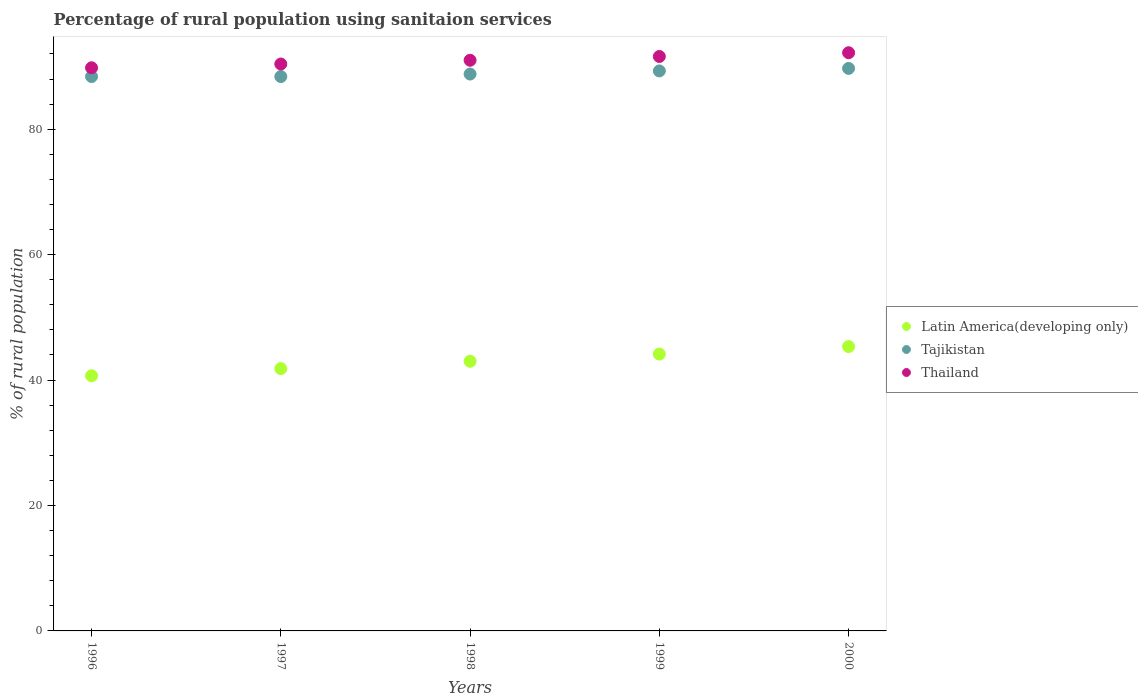Is the number of dotlines equal to the number of legend labels?
Your answer should be very brief. Yes. What is the percentage of rural population using sanitaion services in Tajikistan in 1997?
Provide a short and direct response. 88.4. Across all years, what is the maximum percentage of rural population using sanitaion services in Thailand?
Offer a terse response. 92.2. Across all years, what is the minimum percentage of rural population using sanitaion services in Thailand?
Offer a terse response. 89.8. What is the total percentage of rural population using sanitaion services in Latin America(developing only) in the graph?
Your answer should be very brief. 215.01. What is the difference between the percentage of rural population using sanitaion services in Thailand in 1997 and that in 1999?
Your response must be concise. -1.2. What is the difference between the percentage of rural population using sanitaion services in Latin America(developing only) in 1998 and the percentage of rural population using sanitaion services in Tajikistan in 2000?
Your answer should be very brief. -46.7. What is the average percentage of rural population using sanitaion services in Thailand per year?
Provide a short and direct response. 91. In the year 1996, what is the difference between the percentage of rural population using sanitaion services in Tajikistan and percentage of rural population using sanitaion services in Latin America(developing only)?
Your response must be concise. 47.71. What is the ratio of the percentage of rural population using sanitaion services in Latin America(developing only) in 1996 to that in 2000?
Ensure brevity in your answer.  0.9. Is the percentage of rural population using sanitaion services in Tajikistan in 1997 less than that in 2000?
Ensure brevity in your answer.  Yes. Is the difference between the percentage of rural population using sanitaion services in Tajikistan in 1996 and 1999 greater than the difference between the percentage of rural population using sanitaion services in Latin America(developing only) in 1996 and 1999?
Offer a terse response. Yes. What is the difference between the highest and the second highest percentage of rural population using sanitaion services in Tajikistan?
Your answer should be compact. 0.4. What is the difference between the highest and the lowest percentage of rural population using sanitaion services in Latin America(developing only)?
Your response must be concise. 4.65. In how many years, is the percentage of rural population using sanitaion services in Tajikistan greater than the average percentage of rural population using sanitaion services in Tajikistan taken over all years?
Your answer should be compact. 2. Is it the case that in every year, the sum of the percentage of rural population using sanitaion services in Latin America(developing only) and percentage of rural population using sanitaion services in Thailand  is greater than the percentage of rural population using sanitaion services in Tajikistan?
Your answer should be compact. Yes. Does the percentage of rural population using sanitaion services in Tajikistan monotonically increase over the years?
Ensure brevity in your answer.  No. Is the percentage of rural population using sanitaion services in Latin America(developing only) strictly greater than the percentage of rural population using sanitaion services in Thailand over the years?
Give a very brief answer. No. What is the difference between two consecutive major ticks on the Y-axis?
Your answer should be very brief. 20. Does the graph contain any zero values?
Provide a short and direct response. No. Does the graph contain grids?
Make the answer very short. No. What is the title of the graph?
Offer a very short reply. Percentage of rural population using sanitaion services. What is the label or title of the Y-axis?
Offer a very short reply. % of rural population. What is the % of rural population of Latin America(developing only) in 1996?
Your answer should be very brief. 40.69. What is the % of rural population of Tajikistan in 1996?
Offer a terse response. 88.4. What is the % of rural population in Thailand in 1996?
Offer a terse response. 89.8. What is the % of rural population of Latin America(developing only) in 1997?
Your response must be concise. 41.83. What is the % of rural population of Tajikistan in 1997?
Keep it short and to the point. 88.4. What is the % of rural population in Thailand in 1997?
Offer a very short reply. 90.4. What is the % of rural population of Latin America(developing only) in 1998?
Make the answer very short. 43. What is the % of rural population of Tajikistan in 1998?
Offer a terse response. 88.8. What is the % of rural population of Thailand in 1998?
Make the answer very short. 91. What is the % of rural population of Latin America(developing only) in 1999?
Offer a terse response. 44.15. What is the % of rural population of Tajikistan in 1999?
Your response must be concise. 89.3. What is the % of rural population of Thailand in 1999?
Offer a very short reply. 91.6. What is the % of rural population of Latin America(developing only) in 2000?
Give a very brief answer. 45.34. What is the % of rural population in Tajikistan in 2000?
Offer a terse response. 89.7. What is the % of rural population of Thailand in 2000?
Provide a succinct answer. 92.2. Across all years, what is the maximum % of rural population in Latin America(developing only)?
Offer a terse response. 45.34. Across all years, what is the maximum % of rural population of Tajikistan?
Your response must be concise. 89.7. Across all years, what is the maximum % of rural population of Thailand?
Your answer should be compact. 92.2. Across all years, what is the minimum % of rural population of Latin America(developing only)?
Give a very brief answer. 40.69. Across all years, what is the minimum % of rural population of Tajikistan?
Give a very brief answer. 88.4. Across all years, what is the minimum % of rural population of Thailand?
Your answer should be compact. 89.8. What is the total % of rural population in Latin America(developing only) in the graph?
Give a very brief answer. 215.01. What is the total % of rural population of Tajikistan in the graph?
Make the answer very short. 444.6. What is the total % of rural population of Thailand in the graph?
Offer a terse response. 455. What is the difference between the % of rural population of Latin America(developing only) in 1996 and that in 1997?
Provide a short and direct response. -1.14. What is the difference between the % of rural population in Tajikistan in 1996 and that in 1997?
Your response must be concise. 0. What is the difference between the % of rural population of Latin America(developing only) in 1996 and that in 1998?
Ensure brevity in your answer.  -2.31. What is the difference between the % of rural population in Latin America(developing only) in 1996 and that in 1999?
Offer a very short reply. -3.46. What is the difference between the % of rural population of Thailand in 1996 and that in 1999?
Make the answer very short. -1.8. What is the difference between the % of rural population of Latin America(developing only) in 1996 and that in 2000?
Your response must be concise. -4.65. What is the difference between the % of rural population in Tajikistan in 1996 and that in 2000?
Ensure brevity in your answer.  -1.3. What is the difference between the % of rural population in Thailand in 1996 and that in 2000?
Provide a succinct answer. -2.4. What is the difference between the % of rural population of Latin America(developing only) in 1997 and that in 1998?
Provide a short and direct response. -1.17. What is the difference between the % of rural population of Thailand in 1997 and that in 1998?
Provide a succinct answer. -0.6. What is the difference between the % of rural population of Latin America(developing only) in 1997 and that in 1999?
Offer a very short reply. -2.32. What is the difference between the % of rural population of Latin America(developing only) in 1997 and that in 2000?
Ensure brevity in your answer.  -3.51. What is the difference between the % of rural population of Tajikistan in 1997 and that in 2000?
Ensure brevity in your answer.  -1.3. What is the difference between the % of rural population in Thailand in 1997 and that in 2000?
Give a very brief answer. -1.8. What is the difference between the % of rural population of Latin America(developing only) in 1998 and that in 1999?
Offer a terse response. -1.15. What is the difference between the % of rural population of Tajikistan in 1998 and that in 1999?
Your response must be concise. -0.5. What is the difference between the % of rural population in Thailand in 1998 and that in 1999?
Provide a succinct answer. -0.6. What is the difference between the % of rural population of Latin America(developing only) in 1998 and that in 2000?
Offer a terse response. -2.34. What is the difference between the % of rural population in Latin America(developing only) in 1999 and that in 2000?
Offer a very short reply. -1.19. What is the difference between the % of rural population in Thailand in 1999 and that in 2000?
Offer a very short reply. -0.6. What is the difference between the % of rural population of Latin America(developing only) in 1996 and the % of rural population of Tajikistan in 1997?
Offer a terse response. -47.71. What is the difference between the % of rural population of Latin America(developing only) in 1996 and the % of rural population of Thailand in 1997?
Provide a succinct answer. -49.71. What is the difference between the % of rural population in Tajikistan in 1996 and the % of rural population in Thailand in 1997?
Give a very brief answer. -2. What is the difference between the % of rural population of Latin America(developing only) in 1996 and the % of rural population of Tajikistan in 1998?
Keep it short and to the point. -48.11. What is the difference between the % of rural population of Latin America(developing only) in 1996 and the % of rural population of Thailand in 1998?
Your response must be concise. -50.31. What is the difference between the % of rural population in Latin America(developing only) in 1996 and the % of rural population in Tajikistan in 1999?
Your answer should be very brief. -48.61. What is the difference between the % of rural population in Latin America(developing only) in 1996 and the % of rural population in Thailand in 1999?
Your answer should be compact. -50.91. What is the difference between the % of rural population of Tajikistan in 1996 and the % of rural population of Thailand in 1999?
Give a very brief answer. -3.2. What is the difference between the % of rural population in Latin America(developing only) in 1996 and the % of rural population in Tajikistan in 2000?
Offer a very short reply. -49.01. What is the difference between the % of rural population in Latin America(developing only) in 1996 and the % of rural population in Thailand in 2000?
Make the answer very short. -51.51. What is the difference between the % of rural population of Tajikistan in 1996 and the % of rural population of Thailand in 2000?
Give a very brief answer. -3.8. What is the difference between the % of rural population in Latin America(developing only) in 1997 and the % of rural population in Tajikistan in 1998?
Offer a very short reply. -46.97. What is the difference between the % of rural population in Latin America(developing only) in 1997 and the % of rural population in Thailand in 1998?
Give a very brief answer. -49.17. What is the difference between the % of rural population in Tajikistan in 1997 and the % of rural population in Thailand in 1998?
Provide a short and direct response. -2.6. What is the difference between the % of rural population in Latin America(developing only) in 1997 and the % of rural population in Tajikistan in 1999?
Provide a succinct answer. -47.47. What is the difference between the % of rural population of Latin America(developing only) in 1997 and the % of rural population of Thailand in 1999?
Keep it short and to the point. -49.77. What is the difference between the % of rural population of Latin America(developing only) in 1997 and the % of rural population of Tajikistan in 2000?
Ensure brevity in your answer.  -47.87. What is the difference between the % of rural population in Latin America(developing only) in 1997 and the % of rural population in Thailand in 2000?
Your answer should be very brief. -50.37. What is the difference between the % of rural population of Latin America(developing only) in 1998 and the % of rural population of Tajikistan in 1999?
Make the answer very short. -46.3. What is the difference between the % of rural population of Latin America(developing only) in 1998 and the % of rural population of Thailand in 1999?
Your answer should be very brief. -48.6. What is the difference between the % of rural population of Tajikistan in 1998 and the % of rural population of Thailand in 1999?
Offer a terse response. -2.8. What is the difference between the % of rural population of Latin America(developing only) in 1998 and the % of rural population of Tajikistan in 2000?
Your answer should be very brief. -46.7. What is the difference between the % of rural population in Latin America(developing only) in 1998 and the % of rural population in Thailand in 2000?
Keep it short and to the point. -49.2. What is the difference between the % of rural population of Tajikistan in 1998 and the % of rural population of Thailand in 2000?
Make the answer very short. -3.4. What is the difference between the % of rural population of Latin America(developing only) in 1999 and the % of rural population of Tajikistan in 2000?
Provide a short and direct response. -45.55. What is the difference between the % of rural population in Latin America(developing only) in 1999 and the % of rural population in Thailand in 2000?
Your response must be concise. -48.05. What is the difference between the % of rural population of Tajikistan in 1999 and the % of rural population of Thailand in 2000?
Offer a terse response. -2.9. What is the average % of rural population of Latin America(developing only) per year?
Give a very brief answer. 43. What is the average % of rural population in Tajikistan per year?
Provide a succinct answer. 88.92. What is the average % of rural population in Thailand per year?
Make the answer very short. 91. In the year 1996, what is the difference between the % of rural population of Latin America(developing only) and % of rural population of Tajikistan?
Your response must be concise. -47.71. In the year 1996, what is the difference between the % of rural population of Latin America(developing only) and % of rural population of Thailand?
Provide a short and direct response. -49.11. In the year 1996, what is the difference between the % of rural population in Tajikistan and % of rural population in Thailand?
Give a very brief answer. -1.4. In the year 1997, what is the difference between the % of rural population of Latin America(developing only) and % of rural population of Tajikistan?
Ensure brevity in your answer.  -46.57. In the year 1997, what is the difference between the % of rural population in Latin America(developing only) and % of rural population in Thailand?
Make the answer very short. -48.57. In the year 1997, what is the difference between the % of rural population of Tajikistan and % of rural population of Thailand?
Your answer should be very brief. -2. In the year 1998, what is the difference between the % of rural population in Latin America(developing only) and % of rural population in Tajikistan?
Your answer should be compact. -45.8. In the year 1998, what is the difference between the % of rural population of Latin America(developing only) and % of rural population of Thailand?
Provide a short and direct response. -48. In the year 1998, what is the difference between the % of rural population of Tajikistan and % of rural population of Thailand?
Your response must be concise. -2.2. In the year 1999, what is the difference between the % of rural population in Latin America(developing only) and % of rural population in Tajikistan?
Give a very brief answer. -45.15. In the year 1999, what is the difference between the % of rural population of Latin America(developing only) and % of rural population of Thailand?
Give a very brief answer. -47.45. In the year 1999, what is the difference between the % of rural population in Tajikistan and % of rural population in Thailand?
Provide a succinct answer. -2.3. In the year 2000, what is the difference between the % of rural population in Latin America(developing only) and % of rural population in Tajikistan?
Offer a very short reply. -44.36. In the year 2000, what is the difference between the % of rural population in Latin America(developing only) and % of rural population in Thailand?
Provide a succinct answer. -46.86. In the year 2000, what is the difference between the % of rural population in Tajikistan and % of rural population in Thailand?
Keep it short and to the point. -2.5. What is the ratio of the % of rural population in Latin America(developing only) in 1996 to that in 1997?
Make the answer very short. 0.97. What is the ratio of the % of rural population of Latin America(developing only) in 1996 to that in 1998?
Ensure brevity in your answer.  0.95. What is the ratio of the % of rural population of Tajikistan in 1996 to that in 1998?
Offer a very short reply. 1. What is the ratio of the % of rural population in Thailand in 1996 to that in 1998?
Offer a terse response. 0.99. What is the ratio of the % of rural population in Latin America(developing only) in 1996 to that in 1999?
Your answer should be compact. 0.92. What is the ratio of the % of rural population in Thailand in 1996 to that in 1999?
Provide a short and direct response. 0.98. What is the ratio of the % of rural population in Latin America(developing only) in 1996 to that in 2000?
Offer a very short reply. 0.9. What is the ratio of the % of rural population in Tajikistan in 1996 to that in 2000?
Your answer should be very brief. 0.99. What is the ratio of the % of rural population of Thailand in 1996 to that in 2000?
Offer a very short reply. 0.97. What is the ratio of the % of rural population in Latin America(developing only) in 1997 to that in 1998?
Offer a terse response. 0.97. What is the ratio of the % of rural population in Latin America(developing only) in 1997 to that in 1999?
Offer a terse response. 0.95. What is the ratio of the % of rural population in Thailand in 1997 to that in 1999?
Give a very brief answer. 0.99. What is the ratio of the % of rural population of Latin America(developing only) in 1997 to that in 2000?
Provide a succinct answer. 0.92. What is the ratio of the % of rural population in Tajikistan in 1997 to that in 2000?
Offer a very short reply. 0.99. What is the ratio of the % of rural population of Thailand in 1997 to that in 2000?
Ensure brevity in your answer.  0.98. What is the ratio of the % of rural population in Tajikistan in 1998 to that in 1999?
Make the answer very short. 0.99. What is the ratio of the % of rural population in Latin America(developing only) in 1998 to that in 2000?
Make the answer very short. 0.95. What is the ratio of the % of rural population in Tajikistan in 1998 to that in 2000?
Ensure brevity in your answer.  0.99. What is the ratio of the % of rural population of Thailand in 1998 to that in 2000?
Offer a very short reply. 0.99. What is the ratio of the % of rural population of Latin America(developing only) in 1999 to that in 2000?
Your response must be concise. 0.97. What is the difference between the highest and the second highest % of rural population of Latin America(developing only)?
Offer a very short reply. 1.19. What is the difference between the highest and the second highest % of rural population of Thailand?
Your answer should be compact. 0.6. What is the difference between the highest and the lowest % of rural population of Latin America(developing only)?
Provide a short and direct response. 4.65. 